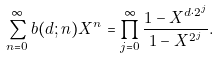Convert formula to latex. <formula><loc_0><loc_0><loc_500><loc_500>\sum _ { n = 0 } ^ { \infty } b ( d ; n ) X ^ { n } = \prod _ { j = 0 } ^ { \infty } \frac { 1 - X ^ { d \cdot 2 ^ { j } } } { 1 - X ^ { 2 ^ { j } } } .</formula> 